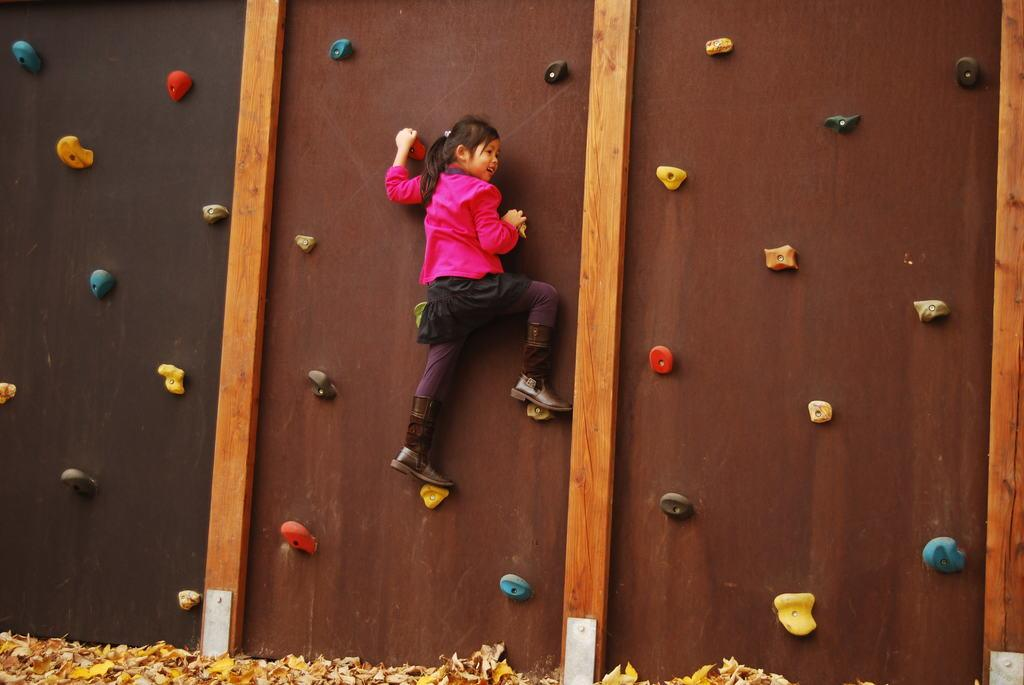Who is the main subject in the image? There is a girl in the image. What is the girl doing in the image? The girl is climbing a wall. What can be seen at the bottom of the image? There are dry leaves at the bottom of the image. What type of bike is the girl riding in the image? There is no bike present in the image; the girl is climbing a wall. How many feet does the girl have in the image? The girl has two feet, but this question is not relevant to the image as it does not require a specific answer based on the facts provided. 